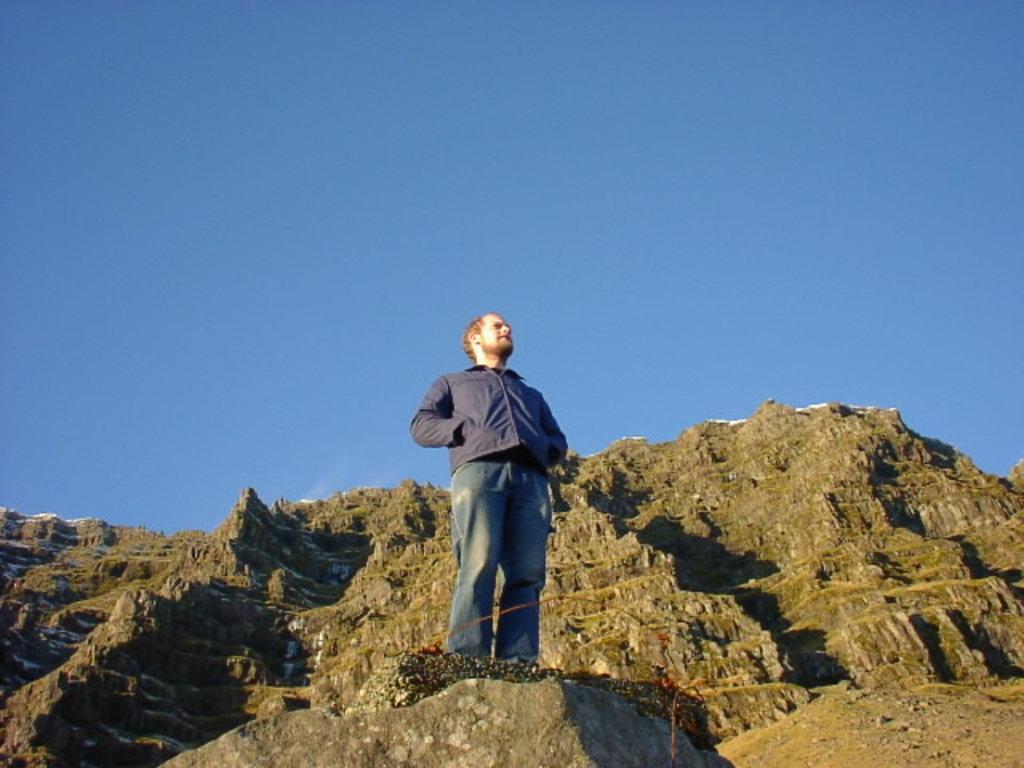How would you summarize this image in a sentence or two? In the center of the image, we can see a man standing and in the background, there are hills and we can see an object. At the top, there is sky. 